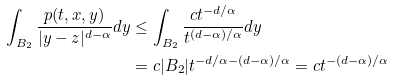<formula> <loc_0><loc_0><loc_500><loc_500>\int _ { B _ { 2 } } \frac { p ( t , x , y ) } { | y - z | ^ { d - \alpha } } d y & \leq \int _ { B _ { 2 } } \frac { c t ^ { - d / \alpha } } { t ^ { ( d - \alpha ) / \alpha } } d y \\ & = c | B _ { 2 } | t ^ { - d / \alpha - ( d - \alpha ) / \alpha } = c t ^ { - ( d - \alpha ) / \alpha }</formula> 